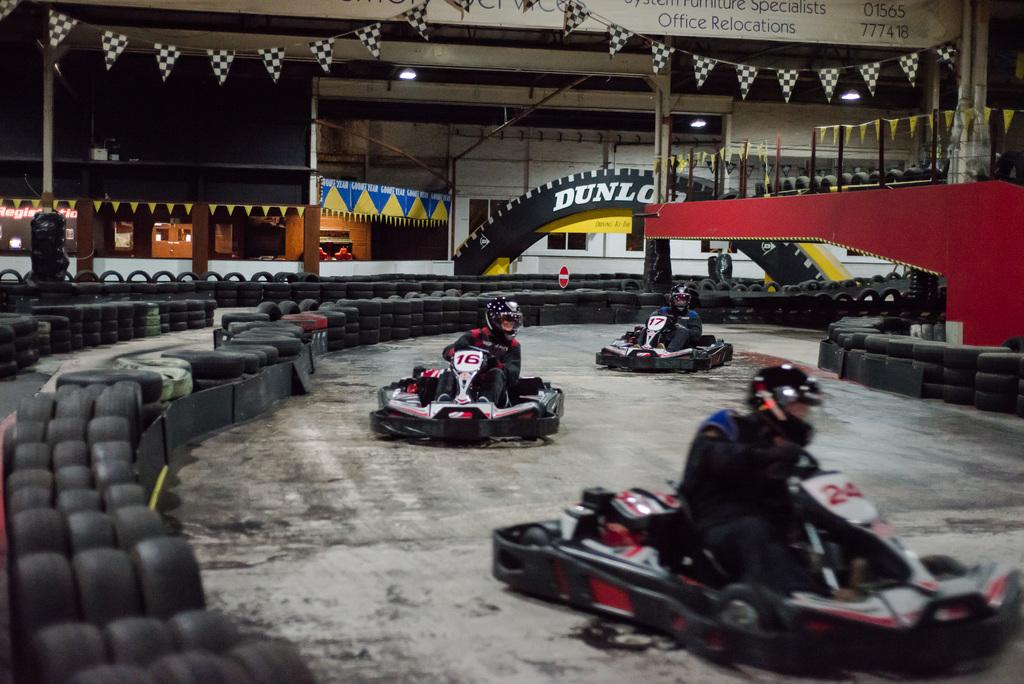What activity is taking place in the image? There is a go karting area in the image, and three persons are riding cars. What can be seen in the background of the image? There are flags and tires in the background of the image. Where is the faucet located in the image? There is no faucet present in the image. How many snakes are slithering around the go karting area in the image? There are no snakes present in the image; the activity taking place is go karting. 